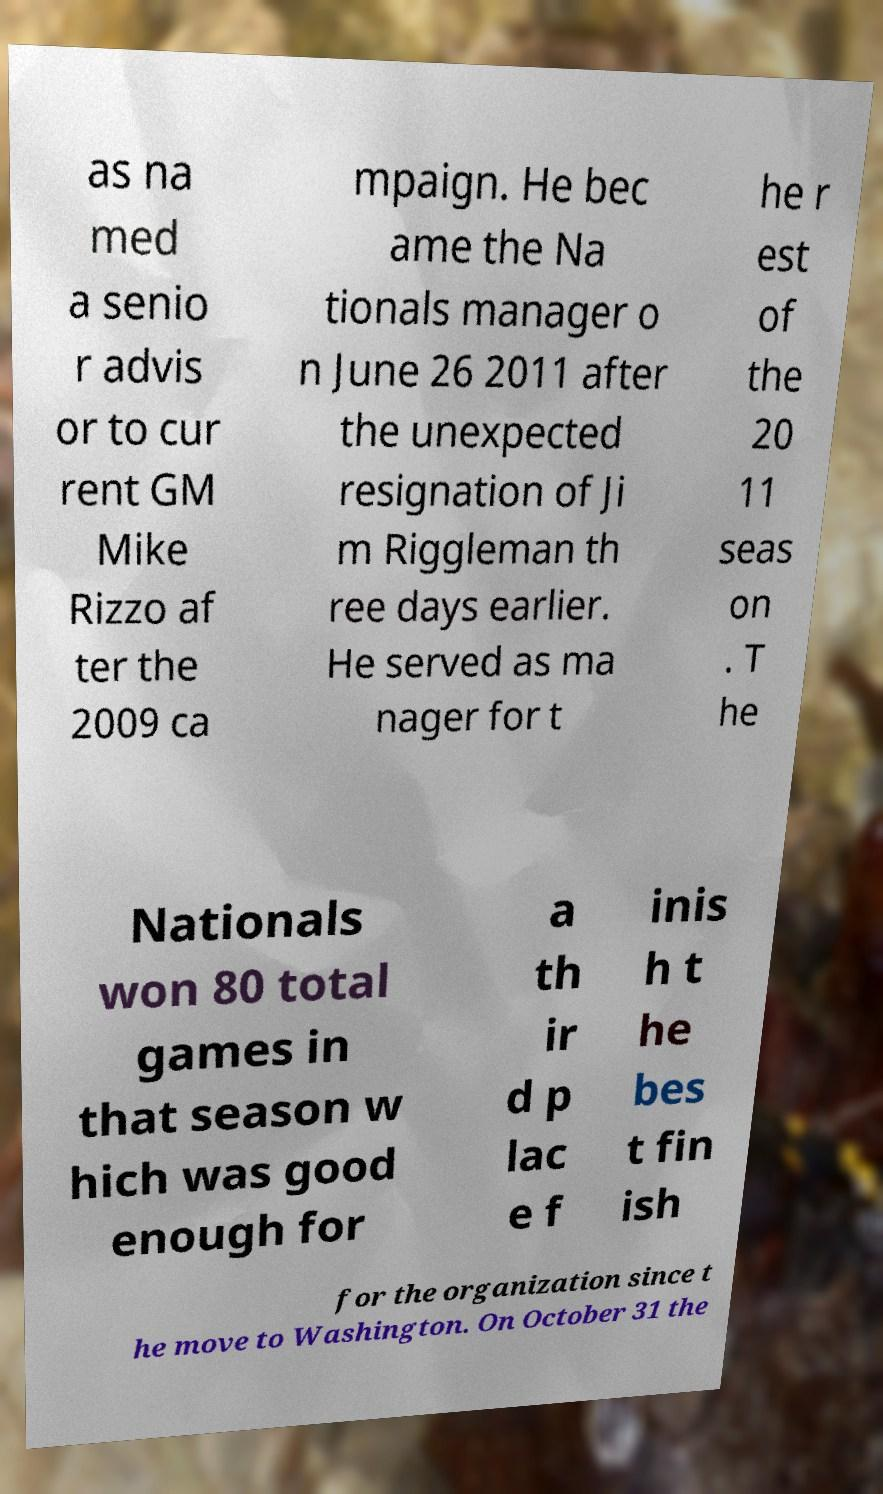Please read and relay the text visible in this image. What does it say? as na med a senio r advis or to cur rent GM Mike Rizzo af ter the 2009 ca mpaign. He bec ame the Na tionals manager o n June 26 2011 after the unexpected resignation of Ji m Riggleman th ree days earlier. He served as ma nager for t he r est of the 20 11 seas on . T he Nationals won 80 total games in that season w hich was good enough for a th ir d p lac e f inis h t he bes t fin ish for the organization since t he move to Washington. On October 31 the 